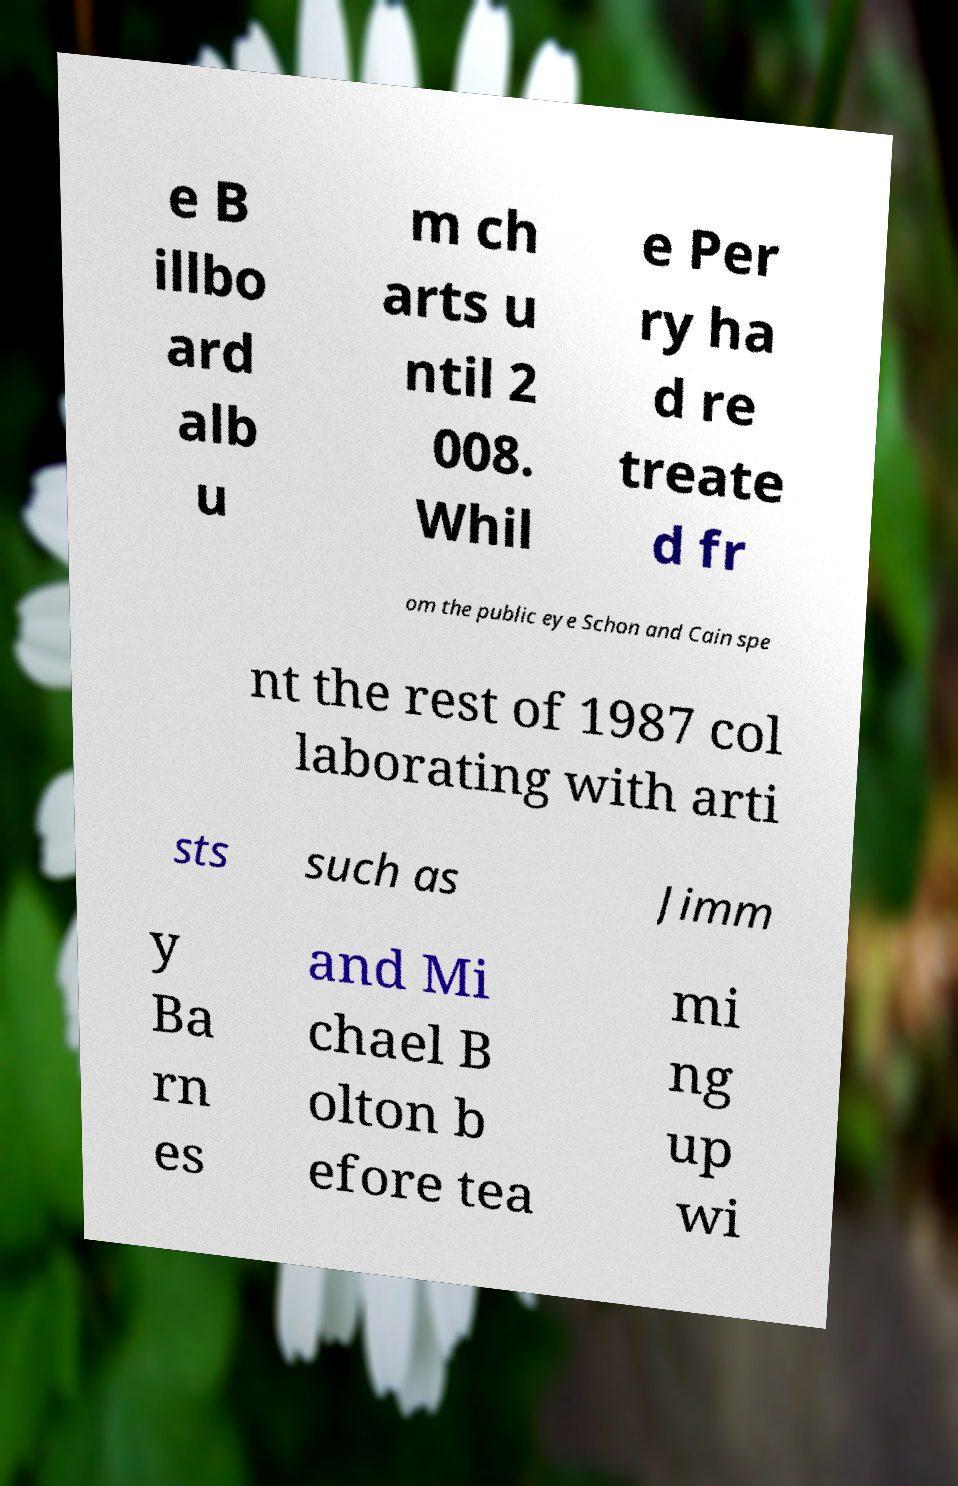There's text embedded in this image that I need extracted. Can you transcribe it verbatim? e B illbo ard alb u m ch arts u ntil 2 008. Whil e Per ry ha d re treate d fr om the public eye Schon and Cain spe nt the rest of 1987 col laborating with arti sts such as Jimm y Ba rn es and Mi chael B olton b efore tea mi ng up wi 